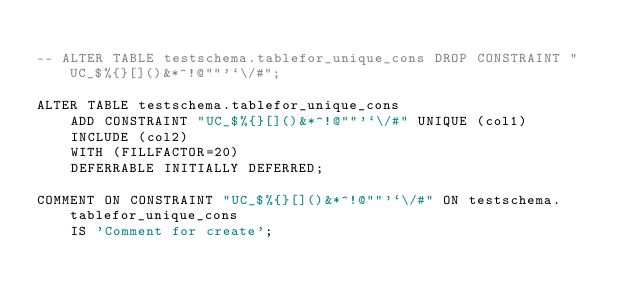<code> <loc_0><loc_0><loc_500><loc_500><_SQL_>
-- ALTER TABLE testschema.tablefor_unique_cons DROP CONSTRAINT "UC_$%{}[]()&*^!@""'`\/#";

ALTER TABLE testschema.tablefor_unique_cons
    ADD CONSTRAINT "UC_$%{}[]()&*^!@""'`\/#" UNIQUE (col1)
    INCLUDE (col2)
    WITH (FILLFACTOR=20)
    DEFERRABLE INITIALLY DEFERRED;

COMMENT ON CONSTRAINT "UC_$%{}[]()&*^!@""'`\/#" ON testschema.tablefor_unique_cons
    IS 'Comment for create';
</code> 